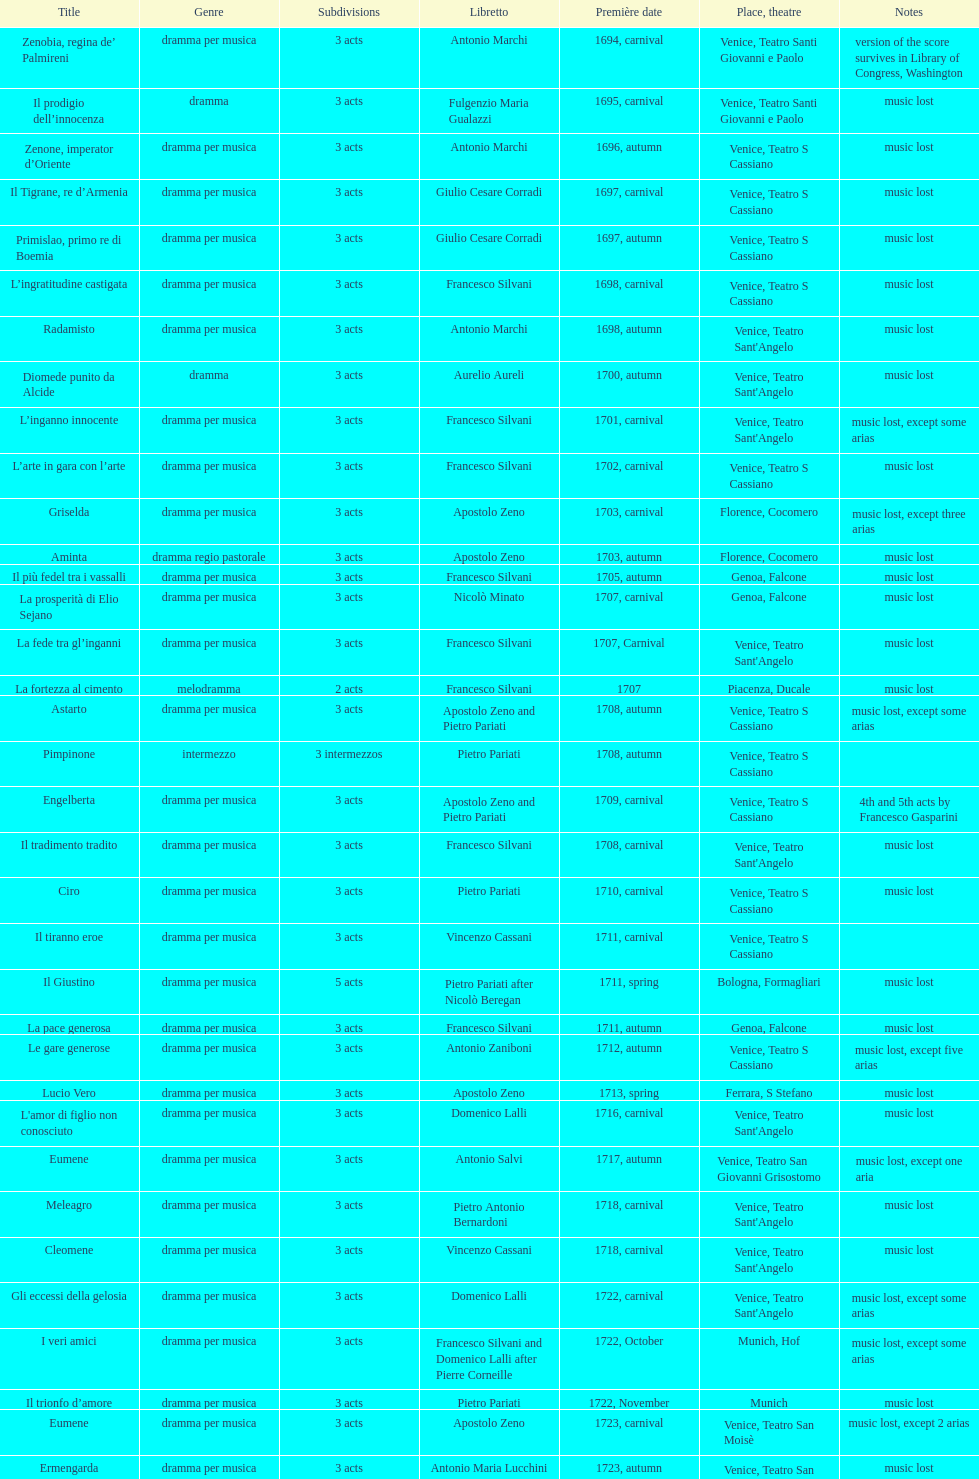L'inganno innocente premiered in 1701. what was the previous title released? Diomede punito da Alcide. I'm looking to parse the entire table for insights. Could you assist me with that? {'header': ['Title', 'Genre', 'Sub\xaddivisions', 'Libretto', 'Première date', 'Place, theatre', 'Notes'], 'rows': [['Zenobia, regina de’ Palmireni', 'dramma per musica', '3 acts', 'Antonio Marchi', '1694, carnival', 'Venice, Teatro Santi Giovanni e Paolo', 'version of the score survives in Library of Congress, Washington'], ['Il prodigio dell’innocenza', 'dramma', '3 acts', 'Fulgenzio Maria Gualazzi', '1695, carnival', 'Venice, Teatro Santi Giovanni e Paolo', 'music lost'], ['Zenone, imperator d’Oriente', 'dramma per musica', '3 acts', 'Antonio Marchi', '1696, autumn', 'Venice, Teatro S Cassiano', 'music lost'], ['Il Tigrane, re d’Armenia', 'dramma per musica', '3 acts', 'Giulio Cesare Corradi', '1697, carnival', 'Venice, Teatro S Cassiano', 'music lost'], ['Primislao, primo re di Boemia', 'dramma per musica', '3 acts', 'Giulio Cesare Corradi', '1697, autumn', 'Venice, Teatro S Cassiano', 'music lost'], ['L’ingratitudine castigata', 'dramma per musica', '3 acts', 'Francesco Silvani', '1698, carnival', 'Venice, Teatro S Cassiano', 'music lost'], ['Radamisto', 'dramma per musica', '3 acts', 'Antonio Marchi', '1698, autumn', "Venice, Teatro Sant'Angelo", 'music lost'], ['Diomede punito da Alcide', 'dramma', '3 acts', 'Aurelio Aureli', '1700, autumn', "Venice, Teatro Sant'Angelo", 'music lost'], ['L’inganno innocente', 'dramma per musica', '3 acts', 'Francesco Silvani', '1701, carnival', "Venice, Teatro Sant'Angelo", 'music lost, except some arias'], ['L’arte in gara con l’arte', 'dramma per musica', '3 acts', 'Francesco Silvani', '1702, carnival', 'Venice, Teatro S Cassiano', 'music lost'], ['Griselda', 'dramma per musica', '3 acts', 'Apostolo Zeno', '1703, carnival', 'Florence, Cocomero', 'music lost, except three arias'], ['Aminta', 'dramma regio pastorale', '3 acts', 'Apostolo Zeno', '1703, autumn', 'Florence, Cocomero', 'music lost'], ['Il più fedel tra i vassalli', 'dramma per musica', '3 acts', 'Francesco Silvani', '1705, autumn', 'Genoa, Falcone', 'music lost'], ['La prosperità di Elio Sejano', 'dramma per musica', '3 acts', 'Nicolò Minato', '1707, carnival', 'Genoa, Falcone', 'music lost'], ['La fede tra gl’inganni', 'dramma per musica', '3 acts', 'Francesco Silvani', '1707, Carnival', "Venice, Teatro Sant'Angelo", 'music lost'], ['La fortezza al cimento', 'melodramma', '2 acts', 'Francesco Silvani', '1707', 'Piacenza, Ducale', 'music lost'], ['Astarto', 'dramma per musica', '3 acts', 'Apostolo Zeno and Pietro Pariati', '1708, autumn', 'Venice, Teatro S Cassiano', 'music lost, except some arias'], ['Pimpinone', 'intermezzo', '3 intermezzos', 'Pietro Pariati', '1708, autumn', 'Venice, Teatro S Cassiano', ''], ['Engelberta', 'dramma per musica', '3 acts', 'Apostolo Zeno and Pietro Pariati', '1709, carnival', 'Venice, Teatro S Cassiano', '4th and 5th acts by Francesco Gasparini'], ['Il tradimento tradito', 'dramma per musica', '3 acts', 'Francesco Silvani', '1708, carnival', "Venice, Teatro Sant'Angelo", 'music lost'], ['Ciro', 'dramma per musica', '3 acts', 'Pietro Pariati', '1710, carnival', 'Venice, Teatro S Cassiano', 'music lost'], ['Il tiranno eroe', 'dramma per musica', '3 acts', 'Vincenzo Cassani', '1711, carnival', 'Venice, Teatro S Cassiano', ''], ['Il Giustino', 'dramma per musica', '5 acts', 'Pietro Pariati after Nicolò Beregan', '1711, spring', 'Bologna, Formagliari', 'music lost'], ['La pace generosa', 'dramma per musica', '3 acts', 'Francesco Silvani', '1711, autumn', 'Genoa, Falcone', 'music lost'], ['Le gare generose', 'dramma per musica', '3 acts', 'Antonio Zaniboni', '1712, autumn', 'Venice, Teatro S Cassiano', 'music lost, except five arias'], ['Lucio Vero', 'dramma per musica', '3 acts', 'Apostolo Zeno', '1713, spring', 'Ferrara, S Stefano', 'music lost'], ["L'amor di figlio non conosciuto", 'dramma per musica', '3 acts', 'Domenico Lalli', '1716, carnival', "Venice, Teatro Sant'Angelo", 'music lost'], ['Eumene', 'dramma per musica', '3 acts', 'Antonio Salvi', '1717, autumn', 'Venice, Teatro San Giovanni Grisostomo', 'music lost, except one aria'], ['Meleagro', 'dramma per musica', '3 acts', 'Pietro Antonio Bernardoni', '1718, carnival', "Venice, Teatro Sant'Angelo", 'music lost'], ['Cleomene', 'dramma per musica', '3 acts', 'Vincenzo Cassani', '1718, carnival', "Venice, Teatro Sant'Angelo", 'music lost'], ['Gli eccessi della gelosia', 'dramma per musica', '3 acts', 'Domenico Lalli', '1722, carnival', "Venice, Teatro Sant'Angelo", 'music lost, except some arias'], ['I veri amici', 'dramma per musica', '3 acts', 'Francesco Silvani and Domenico Lalli after Pierre Corneille', '1722, October', 'Munich, Hof', 'music lost, except some arias'], ['Il trionfo d’amore', 'dramma per musica', '3 acts', 'Pietro Pariati', '1722, November', 'Munich', 'music lost'], ['Eumene', 'dramma per musica', '3 acts', 'Apostolo Zeno', '1723, carnival', 'Venice, Teatro San Moisè', 'music lost, except 2 arias'], ['Ermengarda', 'dramma per musica', '3 acts', 'Antonio Maria Lucchini', '1723, autumn', 'Venice, Teatro San Moisè', 'music lost'], ['Antigono, tutore di Filippo, re di Macedonia', 'tragedia', '5 acts', 'Giovanni Piazzon', '1724, carnival', 'Venice, Teatro San Moisè', '5th act by Giovanni Porta, music lost'], ['Scipione nelle Spagne', 'dramma per musica', '3 acts', 'Apostolo Zeno', '1724, Ascension', 'Venice, Teatro San Samuele', 'music lost'], ['Laodice', 'dramma per musica', '3 acts', 'Angelo Schietti', '1724, autumn', 'Venice, Teatro San Moisè', 'music lost, except 2 arias'], ['Didone abbandonata', 'tragedia', '3 acts', 'Metastasio', '1725, carnival', 'Venice, Teatro S Cassiano', 'music lost'], ["L'impresario delle Isole Canarie", 'intermezzo', '2 acts', 'Metastasio', '1725, carnival', 'Venice, Teatro S Cassiano', 'music lost'], ['Alcina delusa da Ruggero', 'dramma per musica', '3 acts', 'Antonio Marchi', '1725, autumn', 'Venice, Teatro S Cassiano', 'music lost'], ['I rivali generosi', 'dramma per musica', '3 acts', 'Apostolo Zeno', '1725', 'Brescia, Nuovo', ''], ['La Statira', 'dramma per musica', '3 acts', 'Apostolo Zeno and Pietro Pariati', '1726, Carnival', 'Rome, Teatro Capranica', ''], ['Malsazio e Fiammetta', 'intermezzo', '', '', '1726, Carnival', 'Rome, Teatro Capranica', ''], ['Il trionfo di Armida', 'dramma per musica', '3 acts', 'Girolamo Colatelli after Torquato Tasso', '1726, autumn', 'Venice, Teatro San Moisè', 'music lost'], ['L’incostanza schernita', 'dramma comico-pastorale', '3 acts', 'Vincenzo Cassani', '1727, Ascension', 'Venice, Teatro San Samuele', 'music lost, except some arias'], ['Le due rivali in amore', 'dramma per musica', '3 acts', 'Aurelio Aureli', '1728, autumn', 'Venice, Teatro San Moisè', 'music lost'], ['Il Satrapone', 'intermezzo', '', 'Salvi', '1729', 'Parma, Omodeo', ''], ['Li stratagemmi amorosi', 'dramma per musica', '3 acts', 'F Passerini', '1730, carnival', 'Venice, Teatro San Moisè', 'music lost'], ['Elenia', 'dramma per musica', '3 acts', 'Luisa Bergalli', '1730, carnival', "Venice, Teatro Sant'Angelo", 'music lost'], ['Merope', 'dramma', '3 acts', 'Apostolo Zeno', '1731, autumn', 'Prague, Sporck Theater', 'mostly by Albinoni, music lost'], ['Il più infedel tra gli amanti', 'dramma per musica', '3 acts', 'Angelo Schietti', '1731, autumn', 'Treviso, Dolphin', 'music lost'], ['Ardelinda', 'dramma', '3 acts', 'Bartolomeo Vitturi', '1732, autumn', "Venice, Teatro Sant'Angelo", 'music lost, except five arias'], ['Candalide', 'dramma per musica', '3 acts', 'Bartolomeo Vitturi', '1734, carnival', "Venice, Teatro Sant'Angelo", 'music lost'], ['Artamene', 'dramma per musica', '3 acts', 'Bartolomeo Vitturi', '1741, carnival', "Venice, Teatro Sant'Angelo", 'music lost']]} 